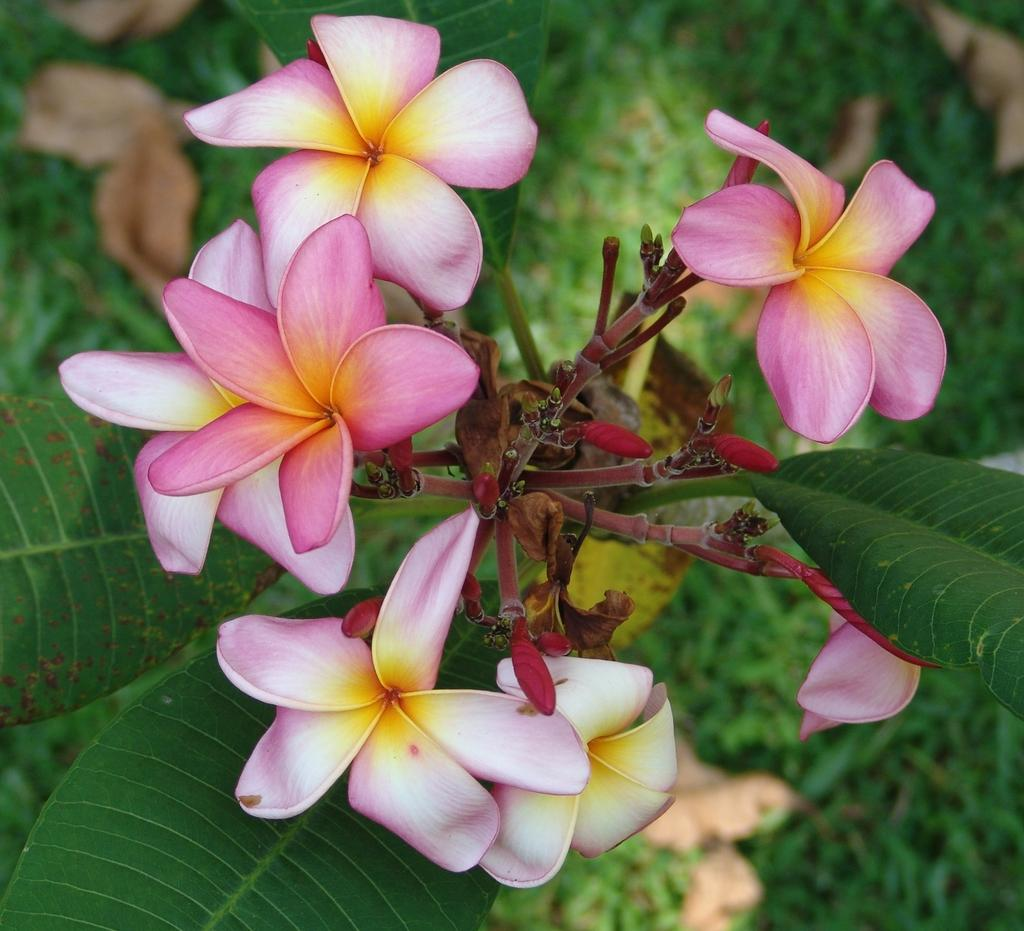What type of plant life is visible in the image? There are flowers, stems, flower buds, and leaves visible in the image. Can you describe the different parts of the plants in the image? Yes, there are flowers, stems, flower buds, and leaves present in the image. What is the background of the image like? The background has a blurred view. What type of fruit is hanging from the stems in the image? There is no fruit visible in the image; it only features flowers, stems, flower buds, and leaves. 